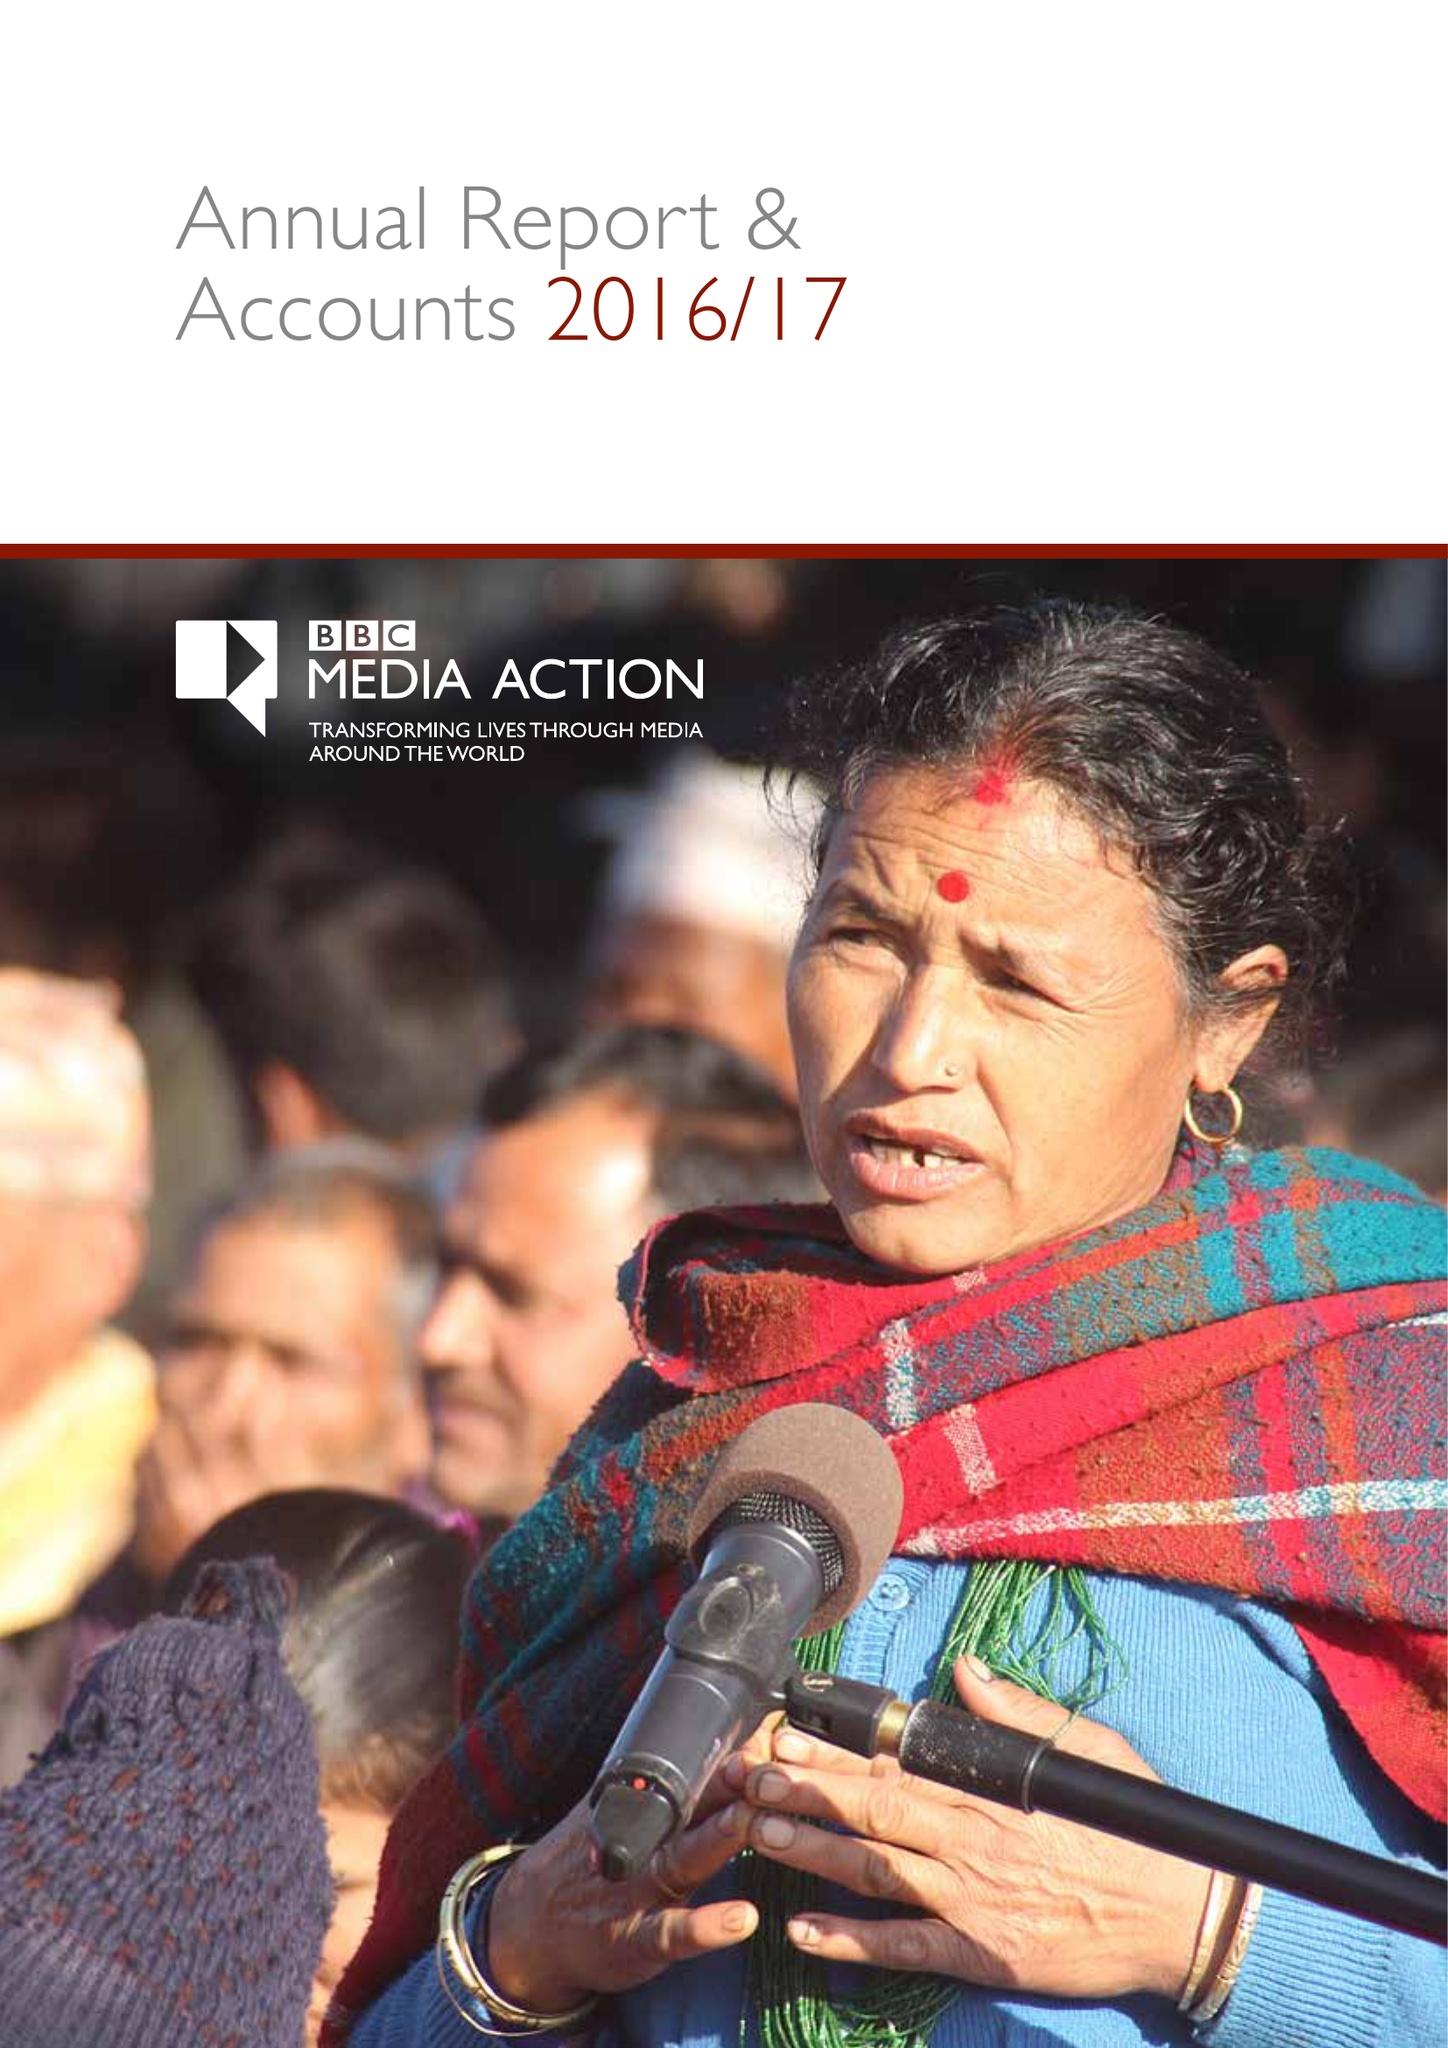What is the value for the address__postcode?
Answer the question using a single word or phrase. W1A 1AA 